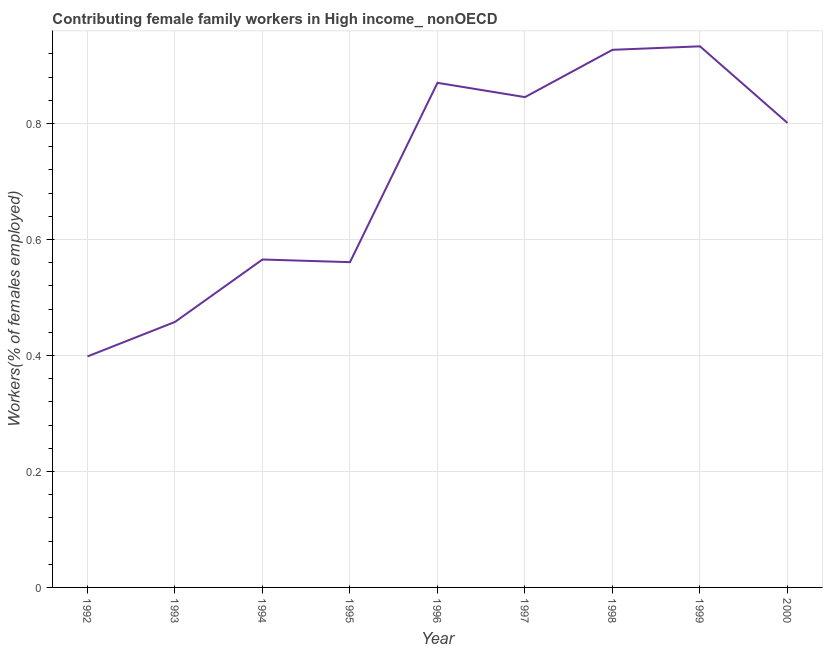What is the contributing female family workers in 1999?
Make the answer very short. 0.93. Across all years, what is the maximum contributing female family workers?
Your answer should be compact. 0.93. Across all years, what is the minimum contributing female family workers?
Provide a succinct answer. 0.4. In which year was the contributing female family workers maximum?
Give a very brief answer. 1999. What is the sum of the contributing female family workers?
Keep it short and to the point. 6.36. What is the difference between the contributing female family workers in 1993 and 2000?
Make the answer very short. -0.34. What is the average contributing female family workers per year?
Make the answer very short. 0.71. What is the median contributing female family workers?
Ensure brevity in your answer.  0.8. In how many years, is the contributing female family workers greater than 0.32 %?
Provide a short and direct response. 9. Do a majority of the years between 1996 and 1992 (inclusive) have contributing female family workers greater than 0.68 %?
Your response must be concise. Yes. What is the ratio of the contributing female family workers in 1996 to that in 2000?
Provide a succinct answer. 1.09. Is the contributing female family workers in 1994 less than that in 1996?
Keep it short and to the point. Yes. Is the difference between the contributing female family workers in 1999 and 2000 greater than the difference between any two years?
Offer a very short reply. No. What is the difference between the highest and the second highest contributing female family workers?
Give a very brief answer. 0.01. What is the difference between the highest and the lowest contributing female family workers?
Your answer should be compact. 0.53. In how many years, is the contributing female family workers greater than the average contributing female family workers taken over all years?
Give a very brief answer. 5. Does the contributing female family workers monotonically increase over the years?
Provide a short and direct response. No. How many years are there in the graph?
Ensure brevity in your answer.  9. Does the graph contain any zero values?
Ensure brevity in your answer.  No. Does the graph contain grids?
Make the answer very short. Yes. What is the title of the graph?
Provide a short and direct response. Contributing female family workers in High income_ nonOECD. What is the label or title of the Y-axis?
Your response must be concise. Workers(% of females employed). What is the Workers(% of females employed) of 1992?
Provide a short and direct response. 0.4. What is the Workers(% of females employed) of 1993?
Provide a succinct answer. 0.46. What is the Workers(% of females employed) in 1994?
Offer a terse response. 0.57. What is the Workers(% of females employed) of 1995?
Your answer should be very brief. 0.56. What is the Workers(% of females employed) of 1996?
Provide a short and direct response. 0.87. What is the Workers(% of females employed) in 1997?
Your answer should be compact. 0.85. What is the Workers(% of females employed) in 1998?
Keep it short and to the point. 0.93. What is the Workers(% of females employed) of 1999?
Provide a succinct answer. 0.93. What is the Workers(% of females employed) of 2000?
Your answer should be compact. 0.8. What is the difference between the Workers(% of females employed) in 1992 and 1993?
Your answer should be compact. -0.06. What is the difference between the Workers(% of females employed) in 1992 and 1994?
Your answer should be very brief. -0.17. What is the difference between the Workers(% of females employed) in 1992 and 1995?
Your response must be concise. -0.16. What is the difference between the Workers(% of females employed) in 1992 and 1996?
Provide a succinct answer. -0.47. What is the difference between the Workers(% of females employed) in 1992 and 1997?
Offer a terse response. -0.45. What is the difference between the Workers(% of females employed) in 1992 and 1998?
Provide a short and direct response. -0.53. What is the difference between the Workers(% of females employed) in 1992 and 1999?
Offer a very short reply. -0.53. What is the difference between the Workers(% of females employed) in 1992 and 2000?
Ensure brevity in your answer.  -0.4. What is the difference between the Workers(% of females employed) in 1993 and 1994?
Keep it short and to the point. -0.11. What is the difference between the Workers(% of females employed) in 1993 and 1995?
Ensure brevity in your answer.  -0.1. What is the difference between the Workers(% of females employed) in 1993 and 1996?
Ensure brevity in your answer.  -0.41. What is the difference between the Workers(% of females employed) in 1993 and 1997?
Give a very brief answer. -0.39. What is the difference between the Workers(% of females employed) in 1993 and 1998?
Offer a very short reply. -0.47. What is the difference between the Workers(% of females employed) in 1993 and 1999?
Provide a short and direct response. -0.48. What is the difference between the Workers(% of females employed) in 1993 and 2000?
Your answer should be very brief. -0.34. What is the difference between the Workers(% of females employed) in 1994 and 1995?
Offer a very short reply. 0. What is the difference between the Workers(% of females employed) in 1994 and 1996?
Provide a succinct answer. -0.3. What is the difference between the Workers(% of females employed) in 1994 and 1997?
Keep it short and to the point. -0.28. What is the difference between the Workers(% of females employed) in 1994 and 1998?
Provide a succinct answer. -0.36. What is the difference between the Workers(% of females employed) in 1994 and 1999?
Ensure brevity in your answer.  -0.37. What is the difference between the Workers(% of females employed) in 1994 and 2000?
Your answer should be compact. -0.24. What is the difference between the Workers(% of females employed) in 1995 and 1996?
Your response must be concise. -0.31. What is the difference between the Workers(% of females employed) in 1995 and 1997?
Ensure brevity in your answer.  -0.28. What is the difference between the Workers(% of females employed) in 1995 and 1998?
Ensure brevity in your answer.  -0.37. What is the difference between the Workers(% of females employed) in 1995 and 1999?
Offer a terse response. -0.37. What is the difference between the Workers(% of females employed) in 1995 and 2000?
Give a very brief answer. -0.24. What is the difference between the Workers(% of females employed) in 1996 and 1997?
Your answer should be compact. 0.02. What is the difference between the Workers(% of females employed) in 1996 and 1998?
Your answer should be very brief. -0.06. What is the difference between the Workers(% of females employed) in 1996 and 1999?
Provide a succinct answer. -0.06. What is the difference between the Workers(% of females employed) in 1996 and 2000?
Your answer should be very brief. 0.07. What is the difference between the Workers(% of females employed) in 1997 and 1998?
Offer a very short reply. -0.08. What is the difference between the Workers(% of females employed) in 1997 and 1999?
Provide a short and direct response. -0.09. What is the difference between the Workers(% of females employed) in 1997 and 2000?
Keep it short and to the point. 0.04. What is the difference between the Workers(% of females employed) in 1998 and 1999?
Your answer should be very brief. -0.01. What is the difference between the Workers(% of females employed) in 1998 and 2000?
Ensure brevity in your answer.  0.13. What is the difference between the Workers(% of females employed) in 1999 and 2000?
Provide a short and direct response. 0.13. What is the ratio of the Workers(% of females employed) in 1992 to that in 1993?
Offer a terse response. 0.87. What is the ratio of the Workers(% of females employed) in 1992 to that in 1994?
Your answer should be compact. 0.7. What is the ratio of the Workers(% of females employed) in 1992 to that in 1995?
Provide a short and direct response. 0.71. What is the ratio of the Workers(% of females employed) in 1992 to that in 1996?
Keep it short and to the point. 0.46. What is the ratio of the Workers(% of females employed) in 1992 to that in 1997?
Keep it short and to the point. 0.47. What is the ratio of the Workers(% of females employed) in 1992 to that in 1998?
Your answer should be compact. 0.43. What is the ratio of the Workers(% of females employed) in 1992 to that in 1999?
Keep it short and to the point. 0.43. What is the ratio of the Workers(% of females employed) in 1992 to that in 2000?
Your answer should be very brief. 0.5. What is the ratio of the Workers(% of females employed) in 1993 to that in 1994?
Your answer should be compact. 0.81. What is the ratio of the Workers(% of females employed) in 1993 to that in 1995?
Offer a terse response. 0.82. What is the ratio of the Workers(% of females employed) in 1993 to that in 1996?
Offer a terse response. 0.53. What is the ratio of the Workers(% of females employed) in 1993 to that in 1997?
Keep it short and to the point. 0.54. What is the ratio of the Workers(% of females employed) in 1993 to that in 1998?
Provide a short and direct response. 0.49. What is the ratio of the Workers(% of females employed) in 1993 to that in 1999?
Your response must be concise. 0.49. What is the ratio of the Workers(% of females employed) in 1993 to that in 2000?
Provide a short and direct response. 0.57. What is the ratio of the Workers(% of females employed) in 1994 to that in 1996?
Keep it short and to the point. 0.65. What is the ratio of the Workers(% of females employed) in 1994 to that in 1997?
Provide a short and direct response. 0.67. What is the ratio of the Workers(% of females employed) in 1994 to that in 1998?
Offer a very short reply. 0.61. What is the ratio of the Workers(% of females employed) in 1994 to that in 1999?
Your answer should be very brief. 0.61. What is the ratio of the Workers(% of females employed) in 1994 to that in 2000?
Offer a very short reply. 0.71. What is the ratio of the Workers(% of females employed) in 1995 to that in 1996?
Offer a very short reply. 0.65. What is the ratio of the Workers(% of females employed) in 1995 to that in 1997?
Keep it short and to the point. 0.66. What is the ratio of the Workers(% of females employed) in 1995 to that in 1998?
Ensure brevity in your answer.  0.6. What is the ratio of the Workers(% of females employed) in 1995 to that in 1999?
Provide a short and direct response. 0.6. What is the ratio of the Workers(% of females employed) in 1995 to that in 2000?
Offer a terse response. 0.7. What is the ratio of the Workers(% of females employed) in 1996 to that in 1997?
Your answer should be very brief. 1.03. What is the ratio of the Workers(% of females employed) in 1996 to that in 1998?
Ensure brevity in your answer.  0.94. What is the ratio of the Workers(% of females employed) in 1996 to that in 1999?
Keep it short and to the point. 0.93. What is the ratio of the Workers(% of females employed) in 1996 to that in 2000?
Provide a succinct answer. 1.09. What is the ratio of the Workers(% of females employed) in 1997 to that in 1998?
Your answer should be very brief. 0.91. What is the ratio of the Workers(% of females employed) in 1997 to that in 1999?
Your answer should be compact. 0.91. What is the ratio of the Workers(% of females employed) in 1997 to that in 2000?
Your answer should be compact. 1.06. What is the ratio of the Workers(% of females employed) in 1998 to that in 2000?
Keep it short and to the point. 1.16. What is the ratio of the Workers(% of females employed) in 1999 to that in 2000?
Offer a terse response. 1.17. 